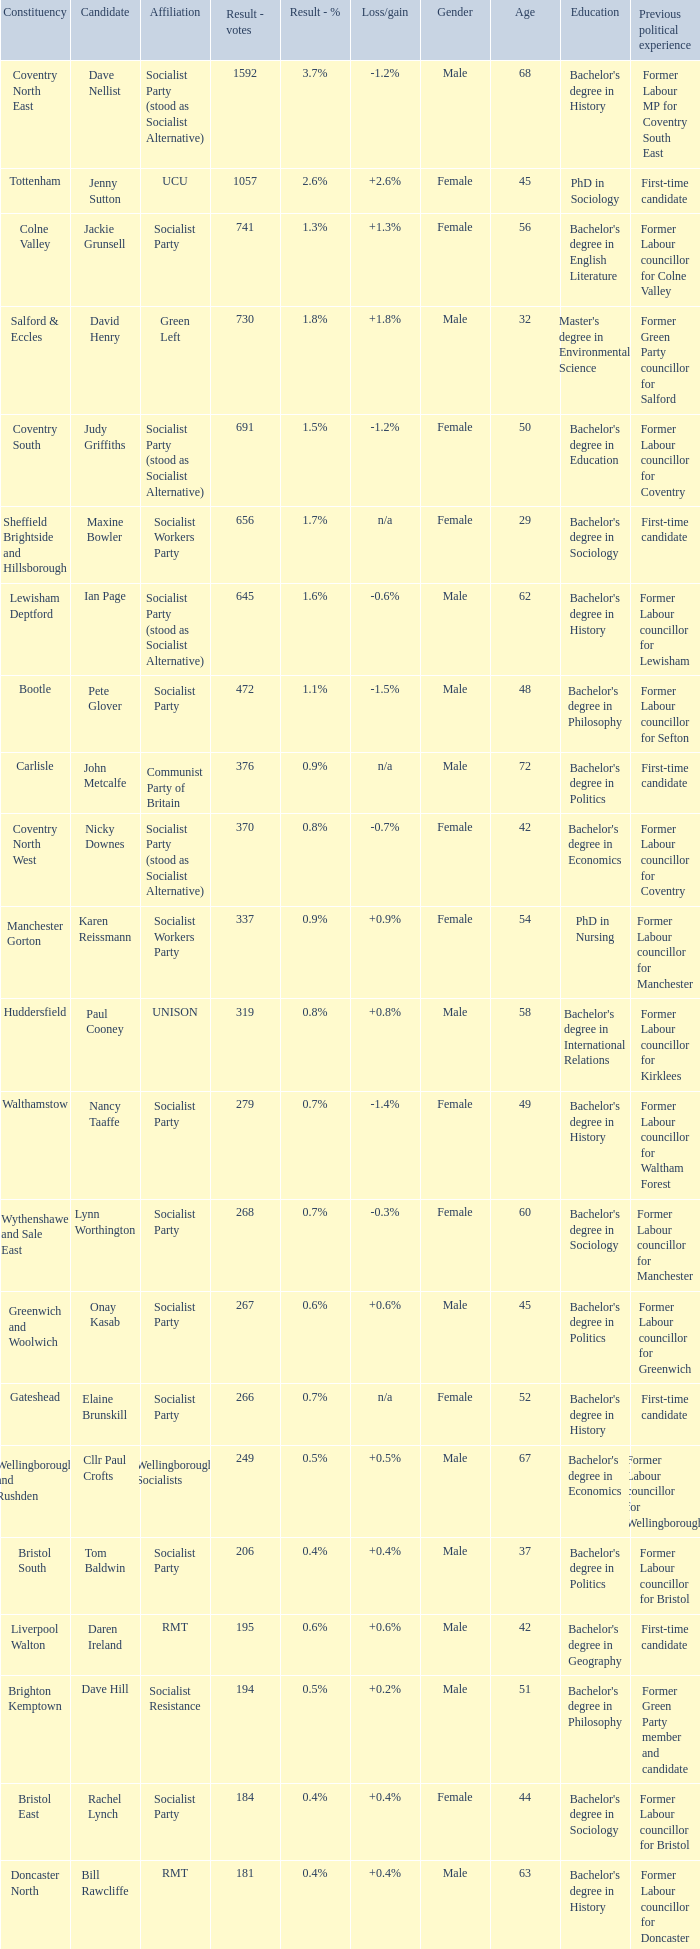What is every affiliation for candidate Daren Ireland? RMT. 